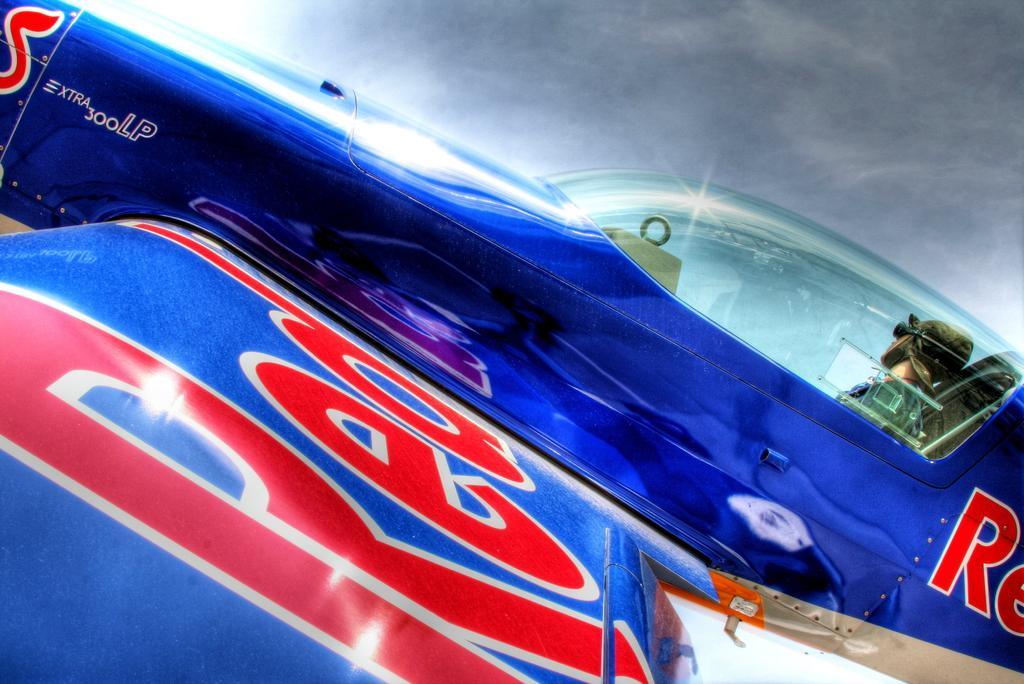<image>
Offer a succinct explanation of the picture presented. A blue plane with the word Red on its wings is ascending 